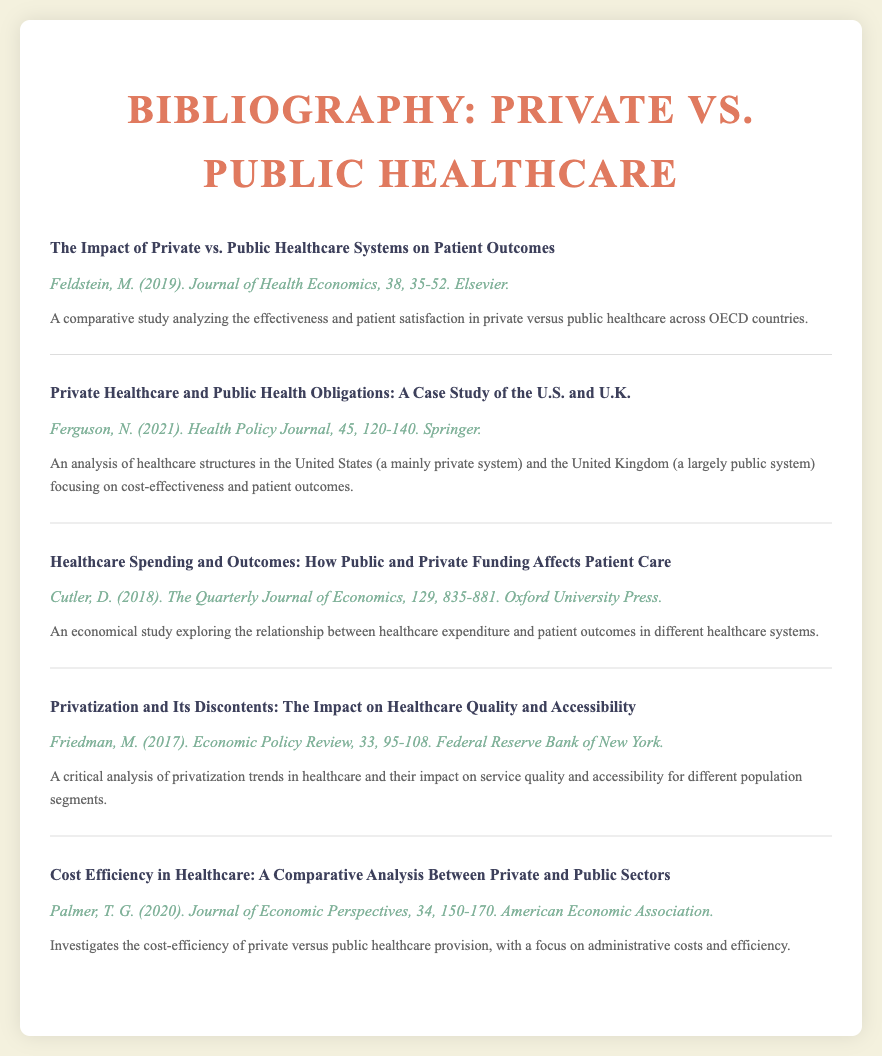What is the title of the first entry? The title of the first entry is the name of the comparative study that analyzes the effectiveness and patient satisfaction in private versus public healthcare across OECD countries.
Answer: The Impact of Private vs. Public Healthcare Systems on Patient Outcomes Who is the author of the second entry? The author of the second entry is the individual who wrote about the healthcare structures in the United States and the United Kingdom.
Answer: Ferguson, N In what year was the study by Cutler published? The publication year of the study exploring the relationship between healthcare expenditure and patient outcomes is indicated in the document.
Answer: 2018 What is the main focus of the fourth entry? The main focus of the fourth entry is the impact of privatization trends in healthcare on service quality and accessibility for different population segments.
Answer: Healthcare quality and accessibility What kind of analysis does Palmer's study provide? Palmer's study investigates the cost-efficiency of private versus public healthcare provision, indicating the nature of the analysis conducted.
Answer: Comparative analysis How many entries are included in the bibliography? The total number of entries in the bibliography reflects the studies compared in the document.
Answer: Five entries 